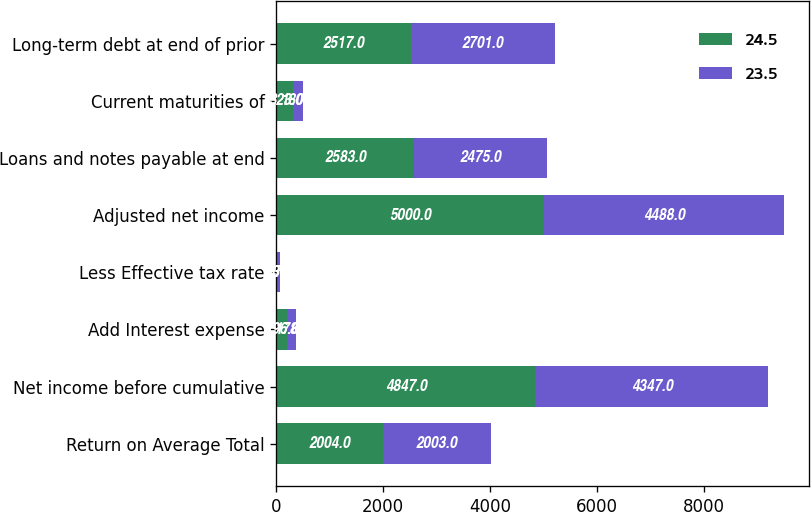Convert chart to OTSL. <chart><loc_0><loc_0><loc_500><loc_500><stacked_bar_chart><ecel><fcel>Return on Average Total<fcel>Net income before cumulative<fcel>Add Interest expense<fcel>Less Effective tax rate<fcel>Adjusted net income<fcel>Loans and notes payable at end<fcel>Current maturities of<fcel>Long-term debt at end of prior<nl><fcel>24.5<fcel>2004<fcel>4847<fcel>196<fcel>43<fcel>5000<fcel>2583<fcel>323<fcel>2517<nl><fcel>23.5<fcel>2003<fcel>4347<fcel>178<fcel>37<fcel>4488<fcel>2475<fcel>180<fcel>2701<nl></chart> 